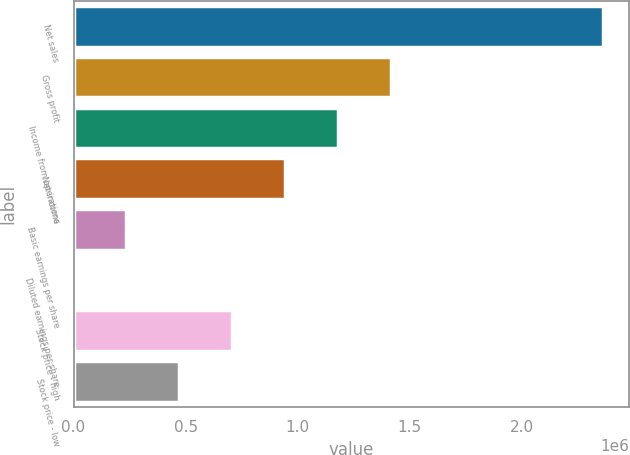Convert chart to OTSL. <chart><loc_0><loc_0><loc_500><loc_500><bar_chart><fcel>Net sales<fcel>Gross profit<fcel>Income from operations<fcel>Net income<fcel>Basic earnings per share<fcel>Diluted earnings per share<fcel>Stock price - high<fcel>Stock price - low<nl><fcel>2.36049e+06<fcel>1.4163e+06<fcel>1.18025e+06<fcel>944198<fcel>236050<fcel>1.31<fcel>708149<fcel>472100<nl></chart> 